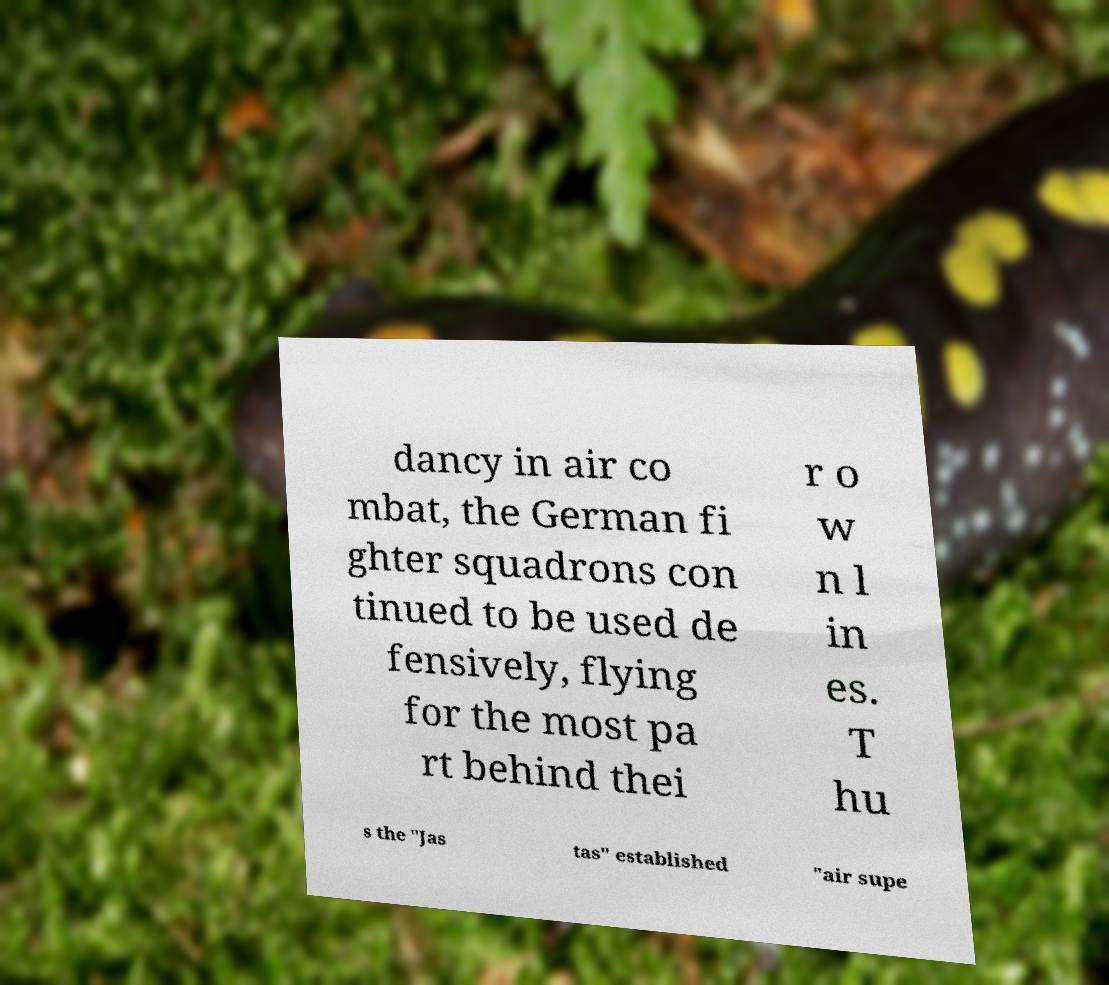Please read and relay the text visible in this image. What does it say? dancy in air co mbat, the German fi ghter squadrons con tinued to be used de fensively, flying for the most pa rt behind thei r o w n l in es. T hu s the "Jas tas" established "air supe 